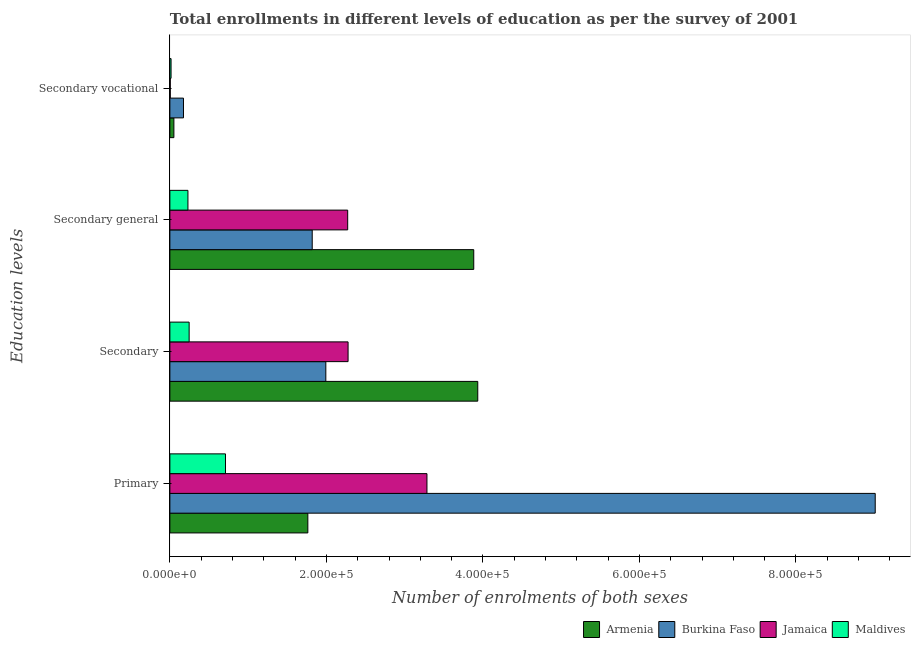How many different coloured bars are there?
Provide a succinct answer. 4. How many bars are there on the 4th tick from the top?
Provide a short and direct response. 4. What is the label of the 3rd group of bars from the top?
Make the answer very short. Secondary. What is the number of enrolments in primary education in Maldives?
Provide a short and direct response. 7.11e+04. Across all countries, what is the maximum number of enrolments in secondary vocational education?
Provide a short and direct response. 1.74e+04. Across all countries, what is the minimum number of enrolments in primary education?
Your answer should be compact. 7.11e+04. In which country was the number of enrolments in secondary vocational education maximum?
Ensure brevity in your answer.  Burkina Faso. In which country was the number of enrolments in primary education minimum?
Your response must be concise. Maldives. What is the total number of enrolments in secondary education in the graph?
Ensure brevity in your answer.  8.45e+05. What is the difference between the number of enrolments in secondary general education in Jamaica and that in Armenia?
Offer a very short reply. -1.61e+05. What is the difference between the number of enrolments in secondary vocational education in Maldives and the number of enrolments in secondary general education in Jamaica?
Give a very brief answer. -2.26e+05. What is the average number of enrolments in secondary vocational education per country?
Your answer should be very brief. 6134.25. What is the difference between the number of enrolments in secondary general education and number of enrolments in secondary education in Maldives?
Your response must be concise. -1521. What is the ratio of the number of enrolments in secondary vocational education in Jamaica to that in Burkina Faso?
Offer a terse response. 0.03. Is the number of enrolments in secondary general education in Armenia less than that in Jamaica?
Keep it short and to the point. No. Is the difference between the number of enrolments in secondary education in Armenia and Burkina Faso greater than the difference between the number of enrolments in secondary vocational education in Armenia and Burkina Faso?
Give a very brief answer. Yes. What is the difference between the highest and the second highest number of enrolments in secondary general education?
Provide a succinct answer. 1.61e+05. What is the difference between the highest and the lowest number of enrolments in secondary general education?
Give a very brief answer. 3.65e+05. Is the sum of the number of enrolments in secondary vocational education in Jamaica and Maldives greater than the maximum number of enrolments in secondary education across all countries?
Offer a very short reply. No. Is it the case that in every country, the sum of the number of enrolments in secondary education and number of enrolments in secondary general education is greater than the sum of number of enrolments in secondary vocational education and number of enrolments in primary education?
Give a very brief answer. Yes. What does the 4th bar from the top in Secondary represents?
Keep it short and to the point. Armenia. What does the 3rd bar from the bottom in Secondary general represents?
Offer a very short reply. Jamaica. Is it the case that in every country, the sum of the number of enrolments in primary education and number of enrolments in secondary education is greater than the number of enrolments in secondary general education?
Give a very brief answer. Yes. How many bars are there?
Your answer should be compact. 16. Where does the legend appear in the graph?
Your answer should be very brief. Bottom right. How many legend labels are there?
Make the answer very short. 4. How are the legend labels stacked?
Your response must be concise. Horizontal. What is the title of the graph?
Offer a very short reply. Total enrollments in different levels of education as per the survey of 2001. What is the label or title of the X-axis?
Offer a terse response. Number of enrolments of both sexes. What is the label or title of the Y-axis?
Your response must be concise. Education levels. What is the Number of enrolments of both sexes of Armenia in Primary?
Offer a very short reply. 1.76e+05. What is the Number of enrolments of both sexes of Burkina Faso in Primary?
Your response must be concise. 9.01e+05. What is the Number of enrolments of both sexes of Jamaica in Primary?
Provide a succinct answer. 3.28e+05. What is the Number of enrolments of both sexes of Maldives in Primary?
Your answer should be compact. 7.11e+04. What is the Number of enrolments of both sexes in Armenia in Secondary?
Provide a succinct answer. 3.93e+05. What is the Number of enrolments of both sexes of Burkina Faso in Secondary?
Offer a very short reply. 1.99e+05. What is the Number of enrolments of both sexes in Jamaica in Secondary?
Your answer should be compact. 2.28e+05. What is the Number of enrolments of both sexes in Maldives in Secondary?
Ensure brevity in your answer.  2.46e+04. What is the Number of enrolments of both sexes in Armenia in Secondary general?
Offer a very short reply. 3.88e+05. What is the Number of enrolments of both sexes of Burkina Faso in Secondary general?
Your answer should be compact. 1.82e+05. What is the Number of enrolments of both sexes of Jamaica in Secondary general?
Your answer should be very brief. 2.27e+05. What is the Number of enrolments of both sexes in Maldives in Secondary general?
Your answer should be compact. 2.31e+04. What is the Number of enrolments of both sexes of Armenia in Secondary vocational?
Provide a succinct answer. 5122. What is the Number of enrolments of both sexes of Burkina Faso in Secondary vocational?
Ensure brevity in your answer.  1.74e+04. What is the Number of enrolments of both sexes in Jamaica in Secondary vocational?
Make the answer very short. 498. What is the Number of enrolments of both sexes of Maldives in Secondary vocational?
Ensure brevity in your answer.  1521. Across all Education levels, what is the maximum Number of enrolments of both sexes of Armenia?
Keep it short and to the point. 3.93e+05. Across all Education levels, what is the maximum Number of enrolments of both sexes in Burkina Faso?
Your answer should be very brief. 9.01e+05. Across all Education levels, what is the maximum Number of enrolments of both sexes of Jamaica?
Make the answer very short. 3.28e+05. Across all Education levels, what is the maximum Number of enrolments of both sexes of Maldives?
Your answer should be very brief. 7.11e+04. Across all Education levels, what is the minimum Number of enrolments of both sexes of Armenia?
Give a very brief answer. 5122. Across all Education levels, what is the minimum Number of enrolments of both sexes in Burkina Faso?
Give a very brief answer. 1.74e+04. Across all Education levels, what is the minimum Number of enrolments of both sexes of Jamaica?
Offer a terse response. 498. Across all Education levels, what is the minimum Number of enrolments of both sexes in Maldives?
Keep it short and to the point. 1521. What is the total Number of enrolments of both sexes of Armenia in the graph?
Your answer should be compact. 9.63e+05. What is the total Number of enrolments of both sexes in Burkina Faso in the graph?
Give a very brief answer. 1.30e+06. What is the total Number of enrolments of both sexes of Jamaica in the graph?
Your answer should be very brief. 7.84e+05. What is the total Number of enrolments of both sexes in Maldives in the graph?
Ensure brevity in your answer.  1.20e+05. What is the difference between the Number of enrolments of both sexes in Armenia in Primary and that in Secondary?
Your response must be concise. -2.17e+05. What is the difference between the Number of enrolments of both sexes in Burkina Faso in Primary and that in Secondary?
Keep it short and to the point. 7.02e+05. What is the difference between the Number of enrolments of both sexes of Jamaica in Primary and that in Secondary?
Provide a short and direct response. 1.01e+05. What is the difference between the Number of enrolments of both sexes in Maldives in Primary and that in Secondary?
Give a very brief answer. 4.64e+04. What is the difference between the Number of enrolments of both sexes in Armenia in Primary and that in Secondary general?
Give a very brief answer. -2.12e+05. What is the difference between the Number of enrolments of both sexes in Burkina Faso in Primary and that in Secondary general?
Offer a terse response. 7.19e+05. What is the difference between the Number of enrolments of both sexes of Jamaica in Primary and that in Secondary general?
Keep it short and to the point. 1.01e+05. What is the difference between the Number of enrolments of both sexes in Maldives in Primary and that in Secondary general?
Provide a short and direct response. 4.80e+04. What is the difference between the Number of enrolments of both sexes in Armenia in Primary and that in Secondary vocational?
Your response must be concise. 1.71e+05. What is the difference between the Number of enrolments of both sexes in Burkina Faso in Primary and that in Secondary vocational?
Provide a short and direct response. 8.84e+05. What is the difference between the Number of enrolments of both sexes in Jamaica in Primary and that in Secondary vocational?
Ensure brevity in your answer.  3.28e+05. What is the difference between the Number of enrolments of both sexes of Maldives in Primary and that in Secondary vocational?
Make the answer very short. 6.95e+04. What is the difference between the Number of enrolments of both sexes in Armenia in Secondary and that in Secondary general?
Provide a short and direct response. 5122. What is the difference between the Number of enrolments of both sexes of Burkina Faso in Secondary and that in Secondary general?
Offer a very short reply. 1.74e+04. What is the difference between the Number of enrolments of both sexes in Jamaica in Secondary and that in Secondary general?
Your answer should be compact. 498. What is the difference between the Number of enrolments of both sexes of Maldives in Secondary and that in Secondary general?
Give a very brief answer. 1521. What is the difference between the Number of enrolments of both sexes in Armenia in Secondary and that in Secondary vocational?
Your response must be concise. 3.88e+05. What is the difference between the Number of enrolments of both sexes in Burkina Faso in Secondary and that in Secondary vocational?
Your answer should be very brief. 1.82e+05. What is the difference between the Number of enrolments of both sexes in Jamaica in Secondary and that in Secondary vocational?
Your answer should be compact. 2.27e+05. What is the difference between the Number of enrolments of both sexes of Maldives in Secondary and that in Secondary vocational?
Provide a succinct answer. 2.31e+04. What is the difference between the Number of enrolments of both sexes of Armenia in Secondary general and that in Secondary vocational?
Give a very brief answer. 3.83e+05. What is the difference between the Number of enrolments of both sexes in Burkina Faso in Secondary general and that in Secondary vocational?
Make the answer very short. 1.64e+05. What is the difference between the Number of enrolments of both sexes in Jamaica in Secondary general and that in Secondary vocational?
Give a very brief answer. 2.27e+05. What is the difference between the Number of enrolments of both sexes in Maldives in Secondary general and that in Secondary vocational?
Ensure brevity in your answer.  2.16e+04. What is the difference between the Number of enrolments of both sexes of Armenia in Primary and the Number of enrolments of both sexes of Burkina Faso in Secondary?
Give a very brief answer. -2.30e+04. What is the difference between the Number of enrolments of both sexes of Armenia in Primary and the Number of enrolments of both sexes of Jamaica in Secondary?
Give a very brief answer. -5.14e+04. What is the difference between the Number of enrolments of both sexes of Armenia in Primary and the Number of enrolments of both sexes of Maldives in Secondary?
Your answer should be very brief. 1.52e+05. What is the difference between the Number of enrolments of both sexes in Burkina Faso in Primary and the Number of enrolments of both sexes in Jamaica in Secondary?
Offer a terse response. 6.74e+05. What is the difference between the Number of enrolments of both sexes in Burkina Faso in Primary and the Number of enrolments of both sexes in Maldives in Secondary?
Your answer should be compact. 8.77e+05. What is the difference between the Number of enrolments of both sexes of Jamaica in Primary and the Number of enrolments of both sexes of Maldives in Secondary?
Make the answer very short. 3.04e+05. What is the difference between the Number of enrolments of both sexes of Armenia in Primary and the Number of enrolments of both sexes of Burkina Faso in Secondary general?
Offer a very short reply. -5580. What is the difference between the Number of enrolments of both sexes in Armenia in Primary and the Number of enrolments of both sexes in Jamaica in Secondary general?
Your response must be concise. -5.09e+04. What is the difference between the Number of enrolments of both sexes in Armenia in Primary and the Number of enrolments of both sexes in Maldives in Secondary general?
Your answer should be very brief. 1.53e+05. What is the difference between the Number of enrolments of both sexes of Burkina Faso in Primary and the Number of enrolments of both sexes of Jamaica in Secondary general?
Offer a very short reply. 6.74e+05. What is the difference between the Number of enrolments of both sexes in Burkina Faso in Primary and the Number of enrolments of both sexes in Maldives in Secondary general?
Keep it short and to the point. 8.78e+05. What is the difference between the Number of enrolments of both sexes of Jamaica in Primary and the Number of enrolments of both sexes of Maldives in Secondary general?
Provide a short and direct response. 3.05e+05. What is the difference between the Number of enrolments of both sexes of Armenia in Primary and the Number of enrolments of both sexes of Burkina Faso in Secondary vocational?
Offer a very short reply. 1.59e+05. What is the difference between the Number of enrolments of both sexes of Armenia in Primary and the Number of enrolments of both sexes of Jamaica in Secondary vocational?
Provide a short and direct response. 1.76e+05. What is the difference between the Number of enrolments of both sexes in Armenia in Primary and the Number of enrolments of both sexes in Maldives in Secondary vocational?
Ensure brevity in your answer.  1.75e+05. What is the difference between the Number of enrolments of both sexes in Burkina Faso in Primary and the Number of enrolments of both sexes in Jamaica in Secondary vocational?
Offer a very short reply. 9.01e+05. What is the difference between the Number of enrolments of both sexes in Burkina Faso in Primary and the Number of enrolments of both sexes in Maldives in Secondary vocational?
Your answer should be very brief. 9.00e+05. What is the difference between the Number of enrolments of both sexes of Jamaica in Primary and the Number of enrolments of both sexes of Maldives in Secondary vocational?
Your answer should be very brief. 3.27e+05. What is the difference between the Number of enrolments of both sexes of Armenia in Secondary and the Number of enrolments of both sexes of Burkina Faso in Secondary general?
Your response must be concise. 2.12e+05. What is the difference between the Number of enrolments of both sexes of Armenia in Secondary and the Number of enrolments of both sexes of Jamaica in Secondary general?
Give a very brief answer. 1.66e+05. What is the difference between the Number of enrolments of both sexes of Armenia in Secondary and the Number of enrolments of both sexes of Maldives in Secondary general?
Give a very brief answer. 3.70e+05. What is the difference between the Number of enrolments of both sexes of Burkina Faso in Secondary and the Number of enrolments of both sexes of Jamaica in Secondary general?
Provide a short and direct response. -2.79e+04. What is the difference between the Number of enrolments of both sexes of Burkina Faso in Secondary and the Number of enrolments of both sexes of Maldives in Secondary general?
Provide a succinct answer. 1.76e+05. What is the difference between the Number of enrolments of both sexes in Jamaica in Secondary and the Number of enrolments of both sexes in Maldives in Secondary general?
Your answer should be very brief. 2.05e+05. What is the difference between the Number of enrolments of both sexes in Armenia in Secondary and the Number of enrolments of both sexes in Burkina Faso in Secondary vocational?
Ensure brevity in your answer.  3.76e+05. What is the difference between the Number of enrolments of both sexes of Armenia in Secondary and the Number of enrolments of both sexes of Jamaica in Secondary vocational?
Your response must be concise. 3.93e+05. What is the difference between the Number of enrolments of both sexes of Armenia in Secondary and the Number of enrolments of both sexes of Maldives in Secondary vocational?
Provide a short and direct response. 3.92e+05. What is the difference between the Number of enrolments of both sexes in Burkina Faso in Secondary and the Number of enrolments of both sexes in Jamaica in Secondary vocational?
Provide a short and direct response. 1.99e+05. What is the difference between the Number of enrolments of both sexes in Burkina Faso in Secondary and the Number of enrolments of both sexes in Maldives in Secondary vocational?
Offer a terse response. 1.98e+05. What is the difference between the Number of enrolments of both sexes in Jamaica in Secondary and the Number of enrolments of both sexes in Maldives in Secondary vocational?
Make the answer very short. 2.26e+05. What is the difference between the Number of enrolments of both sexes in Armenia in Secondary general and the Number of enrolments of both sexes in Burkina Faso in Secondary vocational?
Your answer should be compact. 3.71e+05. What is the difference between the Number of enrolments of both sexes in Armenia in Secondary general and the Number of enrolments of both sexes in Jamaica in Secondary vocational?
Ensure brevity in your answer.  3.88e+05. What is the difference between the Number of enrolments of both sexes in Armenia in Secondary general and the Number of enrolments of both sexes in Maldives in Secondary vocational?
Your answer should be compact. 3.87e+05. What is the difference between the Number of enrolments of both sexes in Burkina Faso in Secondary general and the Number of enrolments of both sexes in Jamaica in Secondary vocational?
Make the answer very short. 1.81e+05. What is the difference between the Number of enrolments of both sexes in Burkina Faso in Secondary general and the Number of enrolments of both sexes in Maldives in Secondary vocational?
Offer a terse response. 1.80e+05. What is the difference between the Number of enrolments of both sexes in Jamaica in Secondary general and the Number of enrolments of both sexes in Maldives in Secondary vocational?
Your answer should be very brief. 2.26e+05. What is the average Number of enrolments of both sexes in Armenia per Education levels?
Keep it short and to the point. 2.41e+05. What is the average Number of enrolments of both sexes in Burkina Faso per Education levels?
Make the answer very short. 3.25e+05. What is the average Number of enrolments of both sexes in Jamaica per Education levels?
Make the answer very short. 1.96e+05. What is the average Number of enrolments of both sexes of Maldives per Education levels?
Keep it short and to the point. 3.01e+04. What is the difference between the Number of enrolments of both sexes in Armenia and Number of enrolments of both sexes in Burkina Faso in Primary?
Ensure brevity in your answer.  -7.25e+05. What is the difference between the Number of enrolments of both sexes in Armenia and Number of enrolments of both sexes in Jamaica in Primary?
Provide a succinct answer. -1.52e+05. What is the difference between the Number of enrolments of both sexes of Armenia and Number of enrolments of both sexes of Maldives in Primary?
Offer a very short reply. 1.05e+05. What is the difference between the Number of enrolments of both sexes in Burkina Faso and Number of enrolments of both sexes in Jamaica in Primary?
Provide a short and direct response. 5.73e+05. What is the difference between the Number of enrolments of both sexes of Burkina Faso and Number of enrolments of both sexes of Maldives in Primary?
Your response must be concise. 8.30e+05. What is the difference between the Number of enrolments of both sexes of Jamaica and Number of enrolments of both sexes of Maldives in Primary?
Your answer should be very brief. 2.57e+05. What is the difference between the Number of enrolments of both sexes of Armenia and Number of enrolments of both sexes of Burkina Faso in Secondary?
Make the answer very short. 1.94e+05. What is the difference between the Number of enrolments of both sexes in Armenia and Number of enrolments of both sexes in Jamaica in Secondary?
Ensure brevity in your answer.  1.66e+05. What is the difference between the Number of enrolments of both sexes of Armenia and Number of enrolments of both sexes of Maldives in Secondary?
Give a very brief answer. 3.69e+05. What is the difference between the Number of enrolments of both sexes in Burkina Faso and Number of enrolments of both sexes in Jamaica in Secondary?
Make the answer very short. -2.84e+04. What is the difference between the Number of enrolments of both sexes in Burkina Faso and Number of enrolments of both sexes in Maldives in Secondary?
Your answer should be compact. 1.75e+05. What is the difference between the Number of enrolments of both sexes in Jamaica and Number of enrolments of both sexes in Maldives in Secondary?
Your answer should be compact. 2.03e+05. What is the difference between the Number of enrolments of both sexes in Armenia and Number of enrolments of both sexes in Burkina Faso in Secondary general?
Make the answer very short. 2.06e+05. What is the difference between the Number of enrolments of both sexes of Armenia and Number of enrolments of both sexes of Jamaica in Secondary general?
Keep it short and to the point. 1.61e+05. What is the difference between the Number of enrolments of both sexes in Armenia and Number of enrolments of both sexes in Maldives in Secondary general?
Keep it short and to the point. 3.65e+05. What is the difference between the Number of enrolments of both sexes of Burkina Faso and Number of enrolments of both sexes of Jamaica in Secondary general?
Offer a terse response. -4.53e+04. What is the difference between the Number of enrolments of both sexes of Burkina Faso and Number of enrolments of both sexes of Maldives in Secondary general?
Your answer should be very brief. 1.59e+05. What is the difference between the Number of enrolments of both sexes in Jamaica and Number of enrolments of both sexes in Maldives in Secondary general?
Offer a terse response. 2.04e+05. What is the difference between the Number of enrolments of both sexes of Armenia and Number of enrolments of both sexes of Burkina Faso in Secondary vocational?
Offer a terse response. -1.23e+04. What is the difference between the Number of enrolments of both sexes in Armenia and Number of enrolments of both sexes in Jamaica in Secondary vocational?
Offer a terse response. 4624. What is the difference between the Number of enrolments of both sexes in Armenia and Number of enrolments of both sexes in Maldives in Secondary vocational?
Your answer should be compact. 3601. What is the difference between the Number of enrolments of both sexes in Burkina Faso and Number of enrolments of both sexes in Jamaica in Secondary vocational?
Give a very brief answer. 1.69e+04. What is the difference between the Number of enrolments of both sexes of Burkina Faso and Number of enrolments of both sexes of Maldives in Secondary vocational?
Your response must be concise. 1.59e+04. What is the difference between the Number of enrolments of both sexes in Jamaica and Number of enrolments of both sexes in Maldives in Secondary vocational?
Provide a short and direct response. -1023. What is the ratio of the Number of enrolments of both sexes of Armenia in Primary to that in Secondary?
Keep it short and to the point. 0.45. What is the ratio of the Number of enrolments of both sexes of Burkina Faso in Primary to that in Secondary?
Provide a short and direct response. 4.52. What is the ratio of the Number of enrolments of both sexes in Jamaica in Primary to that in Secondary?
Keep it short and to the point. 1.44. What is the ratio of the Number of enrolments of both sexes in Maldives in Primary to that in Secondary?
Your answer should be compact. 2.89. What is the ratio of the Number of enrolments of both sexes of Armenia in Primary to that in Secondary general?
Offer a very short reply. 0.45. What is the ratio of the Number of enrolments of both sexes in Burkina Faso in Primary to that in Secondary general?
Offer a terse response. 4.96. What is the ratio of the Number of enrolments of both sexes of Jamaica in Primary to that in Secondary general?
Ensure brevity in your answer.  1.45. What is the ratio of the Number of enrolments of both sexes of Maldives in Primary to that in Secondary general?
Your answer should be compact. 3.08. What is the ratio of the Number of enrolments of both sexes in Armenia in Primary to that in Secondary vocational?
Your answer should be compact. 34.42. What is the ratio of the Number of enrolments of both sexes in Burkina Faso in Primary to that in Secondary vocational?
Your response must be concise. 51.81. What is the ratio of the Number of enrolments of both sexes in Jamaica in Primary to that in Secondary vocational?
Keep it short and to the point. 659.63. What is the ratio of the Number of enrolments of both sexes of Maldives in Primary to that in Secondary vocational?
Keep it short and to the point. 46.72. What is the ratio of the Number of enrolments of both sexes in Armenia in Secondary to that in Secondary general?
Provide a short and direct response. 1.01. What is the ratio of the Number of enrolments of both sexes of Burkina Faso in Secondary to that in Secondary general?
Keep it short and to the point. 1.1. What is the ratio of the Number of enrolments of both sexes in Jamaica in Secondary to that in Secondary general?
Keep it short and to the point. 1. What is the ratio of the Number of enrolments of both sexes of Maldives in Secondary to that in Secondary general?
Provide a short and direct response. 1.07. What is the ratio of the Number of enrolments of both sexes in Armenia in Secondary to that in Secondary vocational?
Offer a very short reply. 76.81. What is the ratio of the Number of enrolments of both sexes of Burkina Faso in Secondary to that in Secondary vocational?
Make the answer very short. 11.46. What is the ratio of the Number of enrolments of both sexes in Jamaica in Secondary to that in Secondary vocational?
Ensure brevity in your answer.  457.23. What is the ratio of the Number of enrolments of both sexes in Maldives in Secondary to that in Secondary vocational?
Offer a terse response. 16.18. What is the ratio of the Number of enrolments of both sexes of Armenia in Secondary general to that in Secondary vocational?
Your answer should be compact. 75.81. What is the ratio of the Number of enrolments of both sexes of Burkina Faso in Secondary general to that in Secondary vocational?
Offer a terse response. 10.46. What is the ratio of the Number of enrolments of both sexes in Jamaica in Secondary general to that in Secondary vocational?
Your answer should be very brief. 456.23. What is the ratio of the Number of enrolments of both sexes of Maldives in Secondary general to that in Secondary vocational?
Keep it short and to the point. 15.18. What is the difference between the highest and the second highest Number of enrolments of both sexes of Armenia?
Offer a very short reply. 5122. What is the difference between the highest and the second highest Number of enrolments of both sexes of Burkina Faso?
Your answer should be very brief. 7.02e+05. What is the difference between the highest and the second highest Number of enrolments of both sexes of Jamaica?
Provide a succinct answer. 1.01e+05. What is the difference between the highest and the second highest Number of enrolments of both sexes in Maldives?
Your response must be concise. 4.64e+04. What is the difference between the highest and the lowest Number of enrolments of both sexes of Armenia?
Your response must be concise. 3.88e+05. What is the difference between the highest and the lowest Number of enrolments of both sexes of Burkina Faso?
Give a very brief answer. 8.84e+05. What is the difference between the highest and the lowest Number of enrolments of both sexes of Jamaica?
Offer a very short reply. 3.28e+05. What is the difference between the highest and the lowest Number of enrolments of both sexes in Maldives?
Offer a terse response. 6.95e+04. 